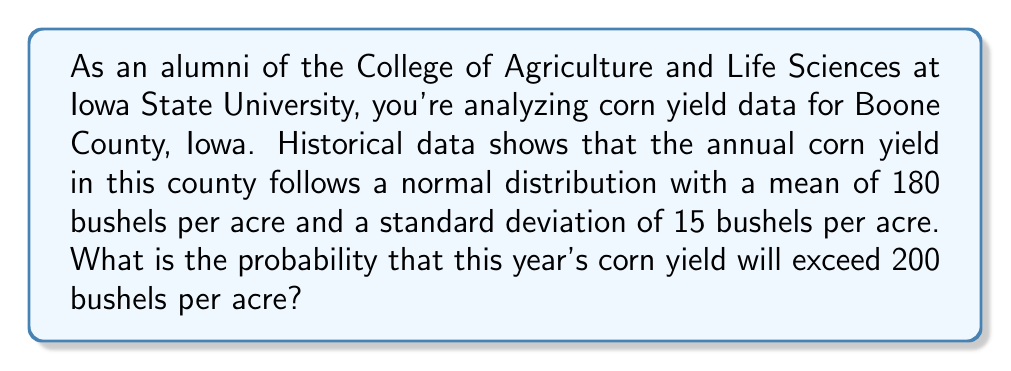Help me with this question. To solve this problem, we need to use the properties of the normal distribution and the concept of z-scores.

1. First, let's identify the given information:
   - Mean (μ) = 180 bushels per acre
   - Standard deviation (σ) = 15 bushels per acre
   - Threshold value = 200 bushels per acre

2. Calculate the z-score for the threshold value:
   $$ z = \frac{x - \mu}{\sigma} $$
   Where x is the threshold value (200 bushels per acre)

   $$ z = \frac{200 - 180}{15} = \frac{20}{15} \approx 1.33 $$

3. The question asks for the probability of exceeding 200 bushels per acre, which is the area to the right of z = 1.33 on the standard normal distribution.

4. Using a standard normal distribution table or calculator, we find the area to the left of z = 1.33:
   $$ P(Z < 1.33) \approx 0.9082 $$

5. The probability we're looking for is the area to the right, which is:
   $$ P(Z > 1.33) = 1 - P(Z < 1.33) = 1 - 0.9082 = 0.0918 $$

6. Convert to a percentage:
   $$ 0.0918 \times 100\% = 9.18\% $$

Therefore, the probability that this year's corn yield will exceed 200 bushels per acre is approximately 9.18%.
Answer: The probability that the corn yield will exceed 200 bushels per acre is approximately 9.18%. 